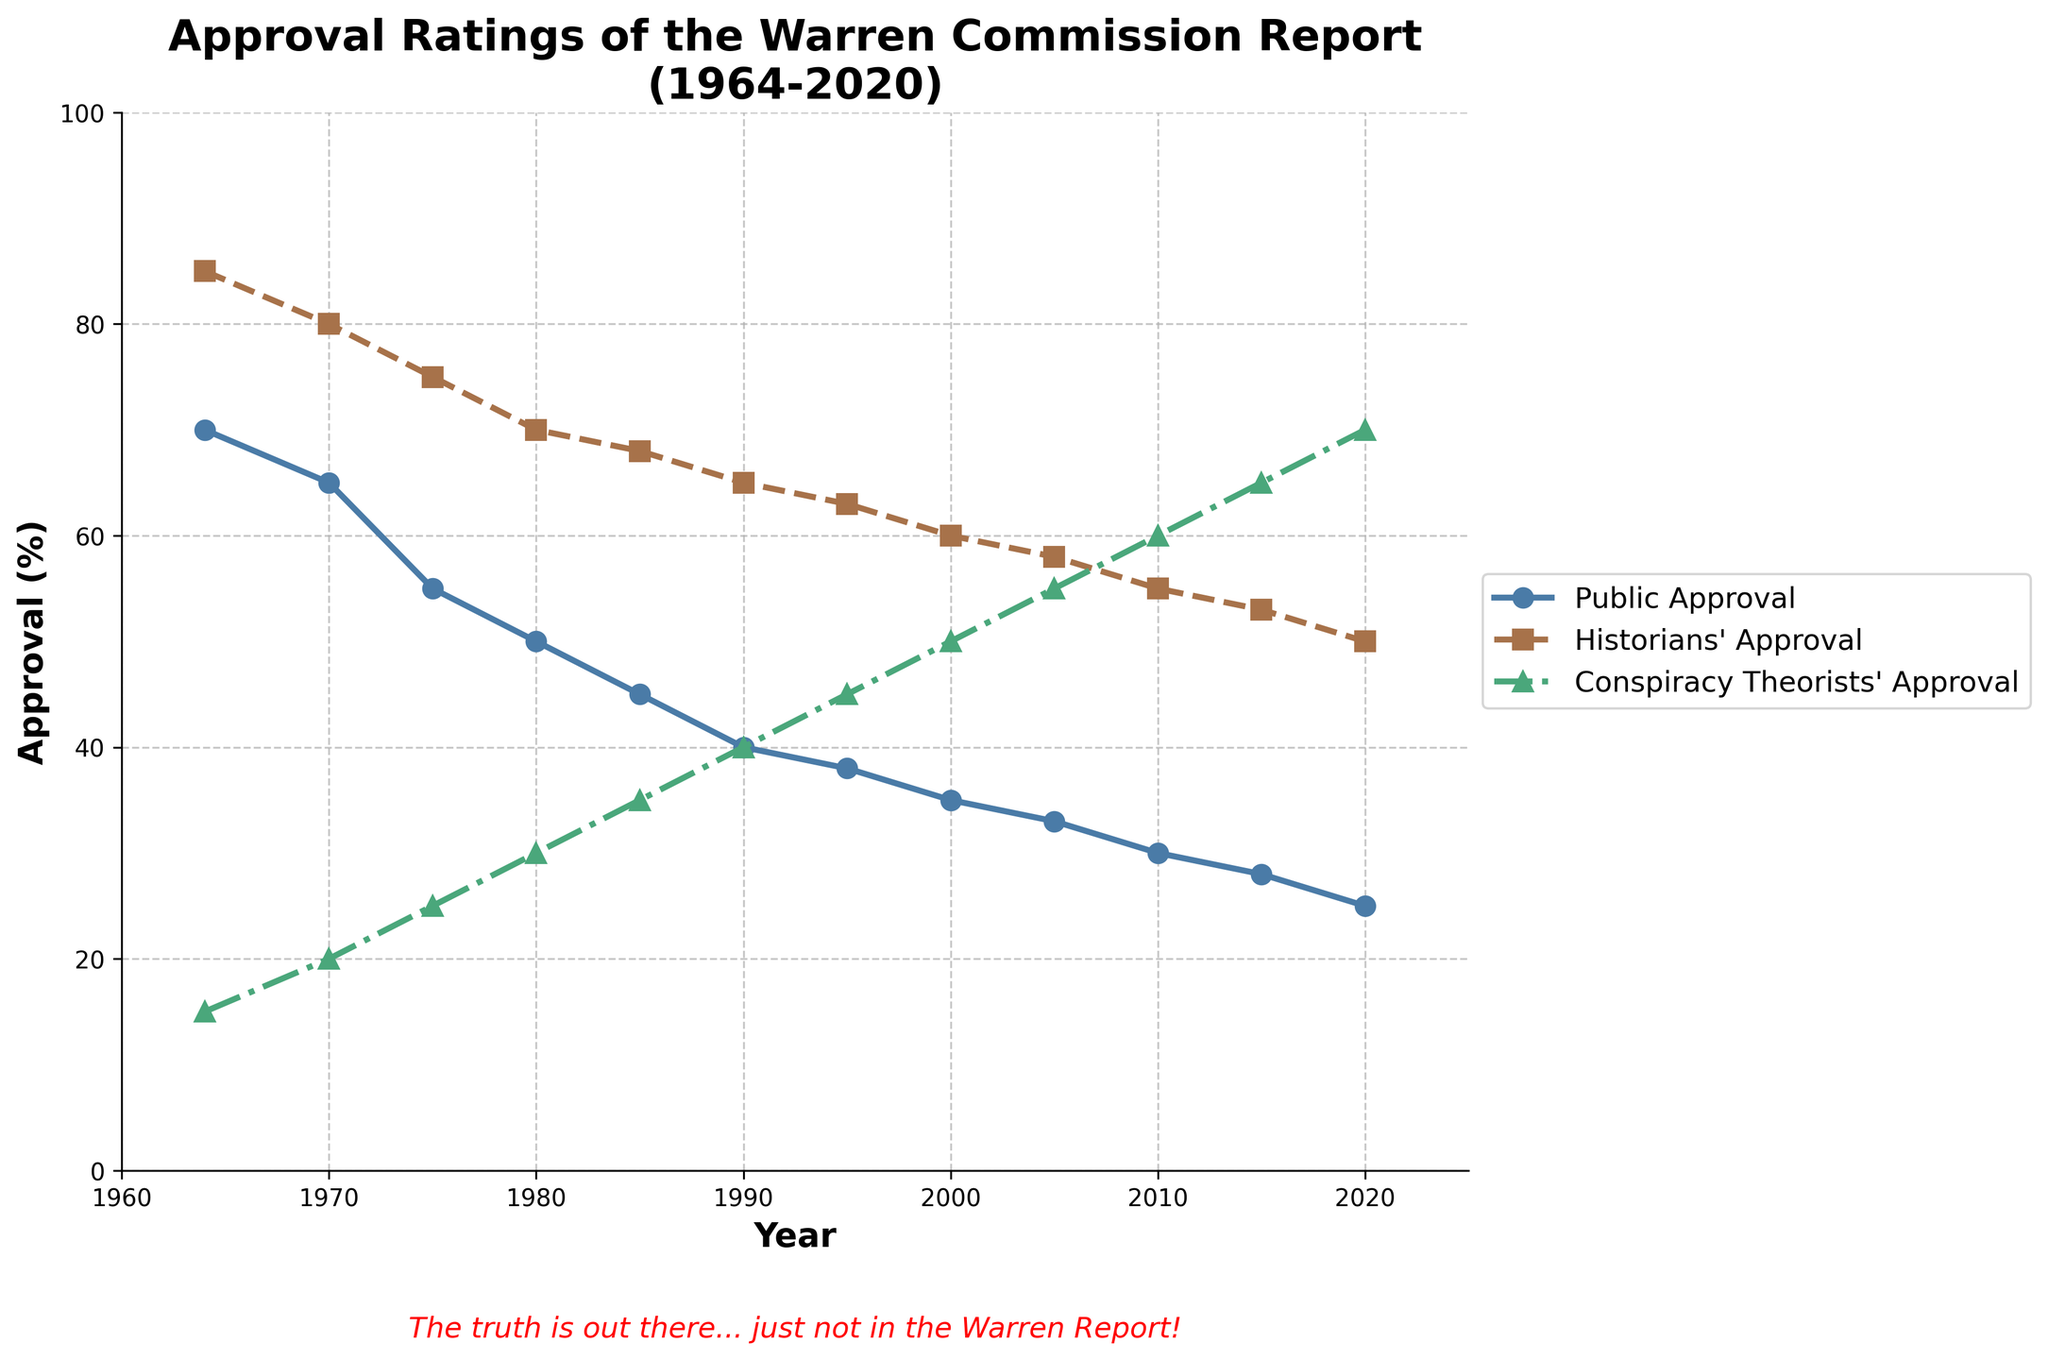Which group has the highest approval rating in 1964? By looking at the year 1964 on the x-axis and checking the heights of the lines, we can see that the historians' approval is the highest at 85%.
Answer: Historians How has public approval changed from 1964 to 2020? By checking the public approval line from 1964 to 2020, we observe a continuous decline from 70% in 1964 to 25% in 2020.
Answer: Decreased What is the average approval percentage for conspiracy theorists in 1980 and 1990? The approval ratings for conspiracy theorists in 1980 and 1990 are 30% and 40%, respectively. The average can be calculated as (30 + 40) / 2 = 35%.
Answer: 35% What trend is observed in the historians' approval from 1964 to 2020? By examining the historians' approval line from 1964 to 2020, we see a steady decline from 85% to 50%.
Answer: Steady decline In which year did the public approval drop below 40%? Observing the public approval line, we see that it first drops below 40% in 1995.
Answer: 1995 How does the approval rating of conspiracy theorists in 2020 compare to their approval rating in 1964? The approval rating for conspiracy theorists in 1964 was 15%, while in 2020 it increased to 70%. This is an increase.
Answer: Increased What is the difference between historians’ and public approval in 1985? The historians' approval in 1985 is 68%, and the public approval is 45%. The difference is 68% - 45% = 23%.
Answer: 23% Which year saw the smallest gap between public and conspiracy theorists' approval? By comparing the gaps over the years, the smallest gap is in 2020, where public approval is 25% and conspiracy theorists' approval is 70%, a 45% difference.
Answer: 2020 